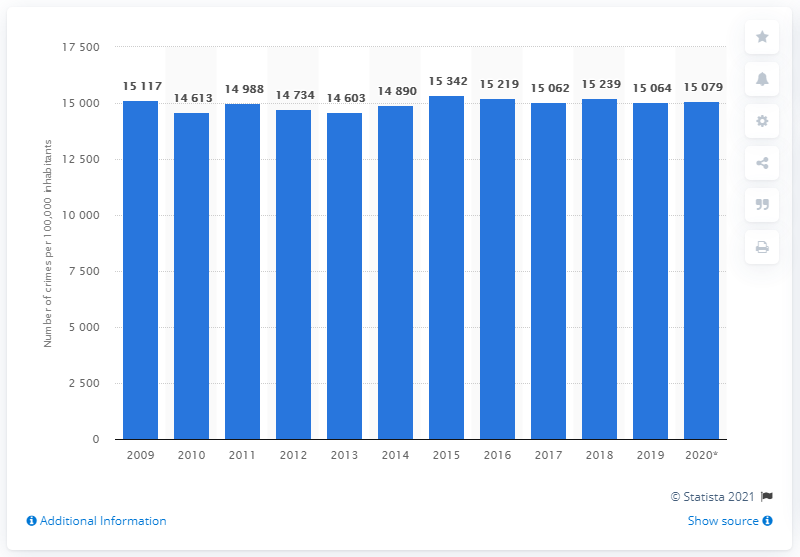Can you comment on the statistical significance of the changes in the crime rates over these years? The bar graph doesn't provide statistical significance indicators such as confidence intervals or p-values. To comment on the statistical significance, we would need access to the underlying data and perform statistical tests. General fluctuations are visible, but without statistical analysis, we cannot confidently say whether these changes are significant or due to random variation. 